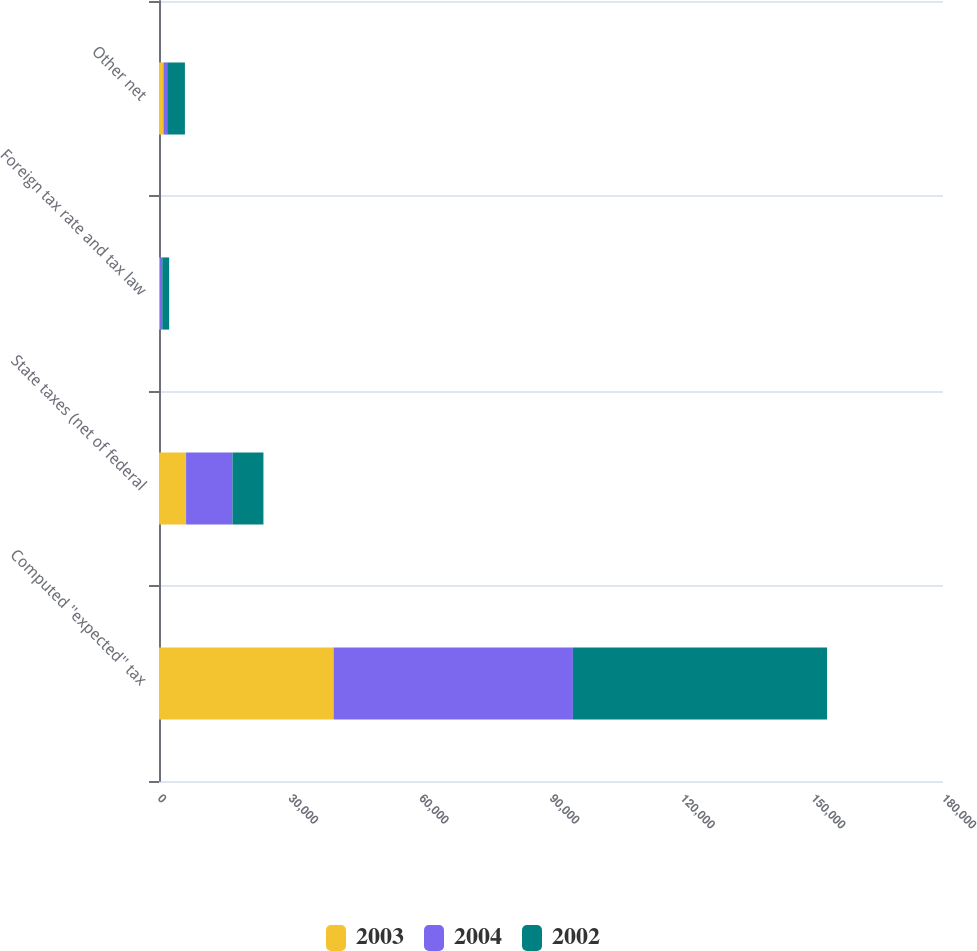<chart> <loc_0><loc_0><loc_500><loc_500><stacked_bar_chart><ecel><fcel>Computed ''expected'' tax<fcel>State taxes (net of federal<fcel>Foreign tax rate and tax law<fcel>Other net<nl><fcel>2003<fcel>40082<fcel>6220<fcel>209<fcel>1015<nl><fcel>2004<fcel>54946<fcel>10650<fcel>540<fcel>865<nl><fcel>2002<fcel>58357<fcel>7107<fcel>1584<fcel>4069<nl></chart> 